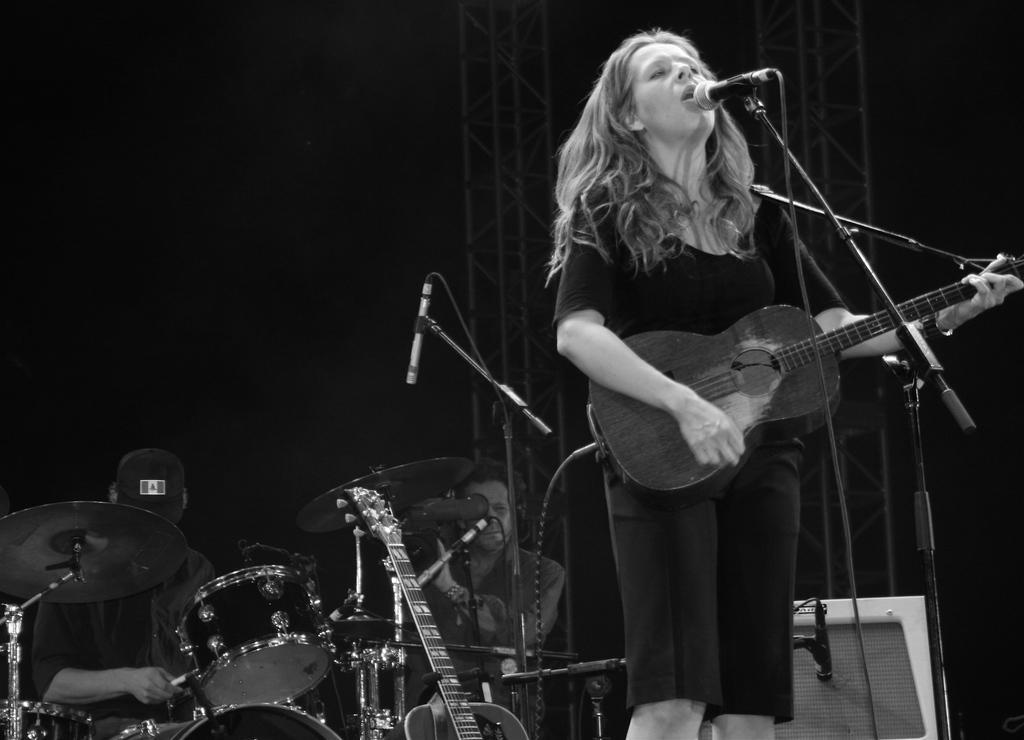Can you describe this image briefly? In this image I can see a woman is standing and holding a guitar. I can also see a mic in front of her. In the background I can see a person next to a drum set and here I can see one more guitar and other mic. 